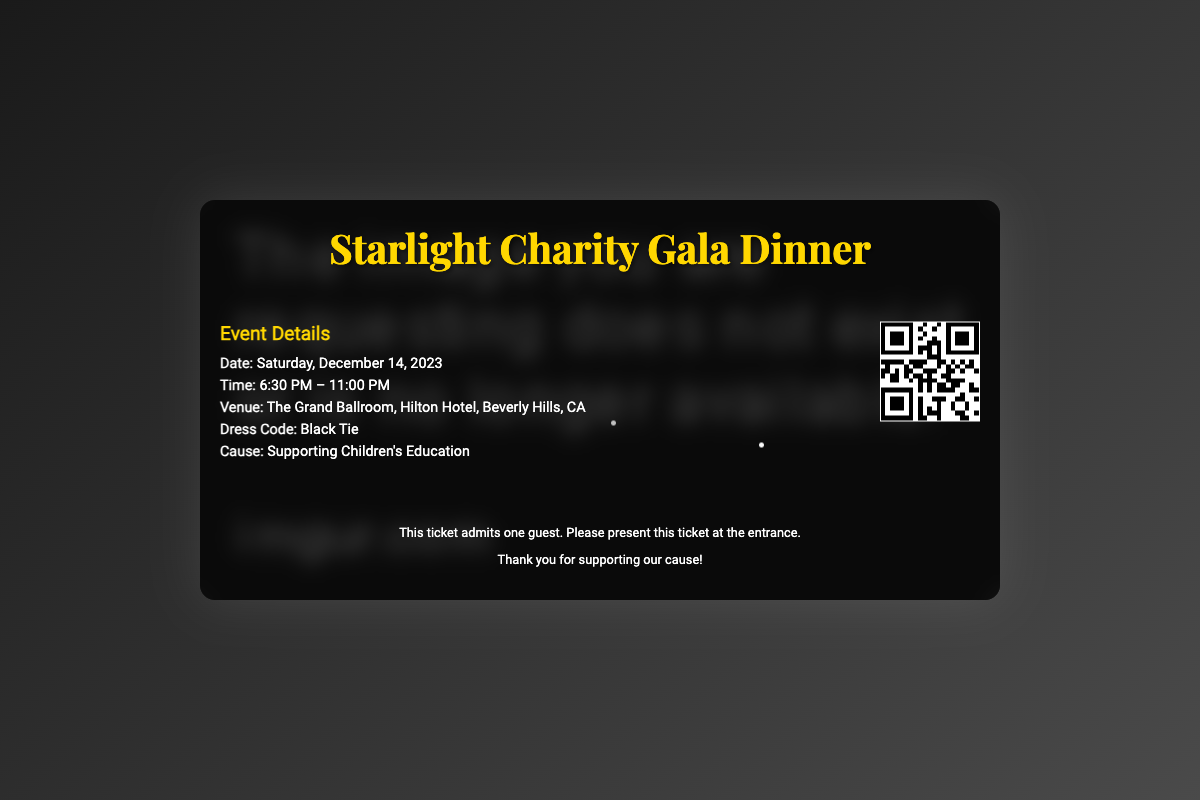What is the event date? The event date is explicitly stated in the document as "Saturday, December 14, 2023".
Answer: Saturday, December 14, 2023 What is the time of the event? The document outlines the event time as "6:30 PM – 11:00 PM".
Answer: 6:30 PM – 11:00 PM What is the venue for the gala dinner? The venue is specified in the document as "The Grand Ballroom, Hilton Hotel, Beverly Hills, CA".
Answer: The Grand Ballroom, Hilton Hotel, Beverly Hills, CA What is the dress code? The dress code is clearly indicated as "Black Tie" in the document.
Answer: Black Tie What is the cause of the event? The document mentions the cause as "Supporting Children's Education".
Answer: Supporting Children's Education What type of ticket is this? The ticket is defined as admitting "one guest" in the document.
Answer: one guest Why is the event significant? The significance stems from the document stating it supports "Children's Education".
Answer: Children's Education What type of content is this document? The document is a "Ticket" for the Starlight Charity Gala Dinner.
Answer: Ticket 